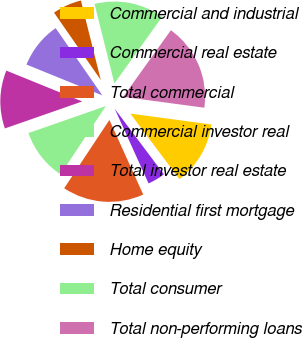Convert chart to OTSL. <chart><loc_0><loc_0><loc_500><loc_500><pie_chart><fcel>Commercial and industrial<fcel>Commercial real estate<fcel>Total commercial<fcel>Commercial investor real<fcel>Total investor real estate<fcel>Residential first mortgage<fcel>Home equity<fcel>Total consumer<fcel>Total non-performing loans<nl><fcel>12.64%<fcel>3.47%<fcel>16.08%<fcel>10.35%<fcel>11.49%<fcel>9.2%<fcel>5.76%<fcel>13.79%<fcel>17.23%<nl></chart> 